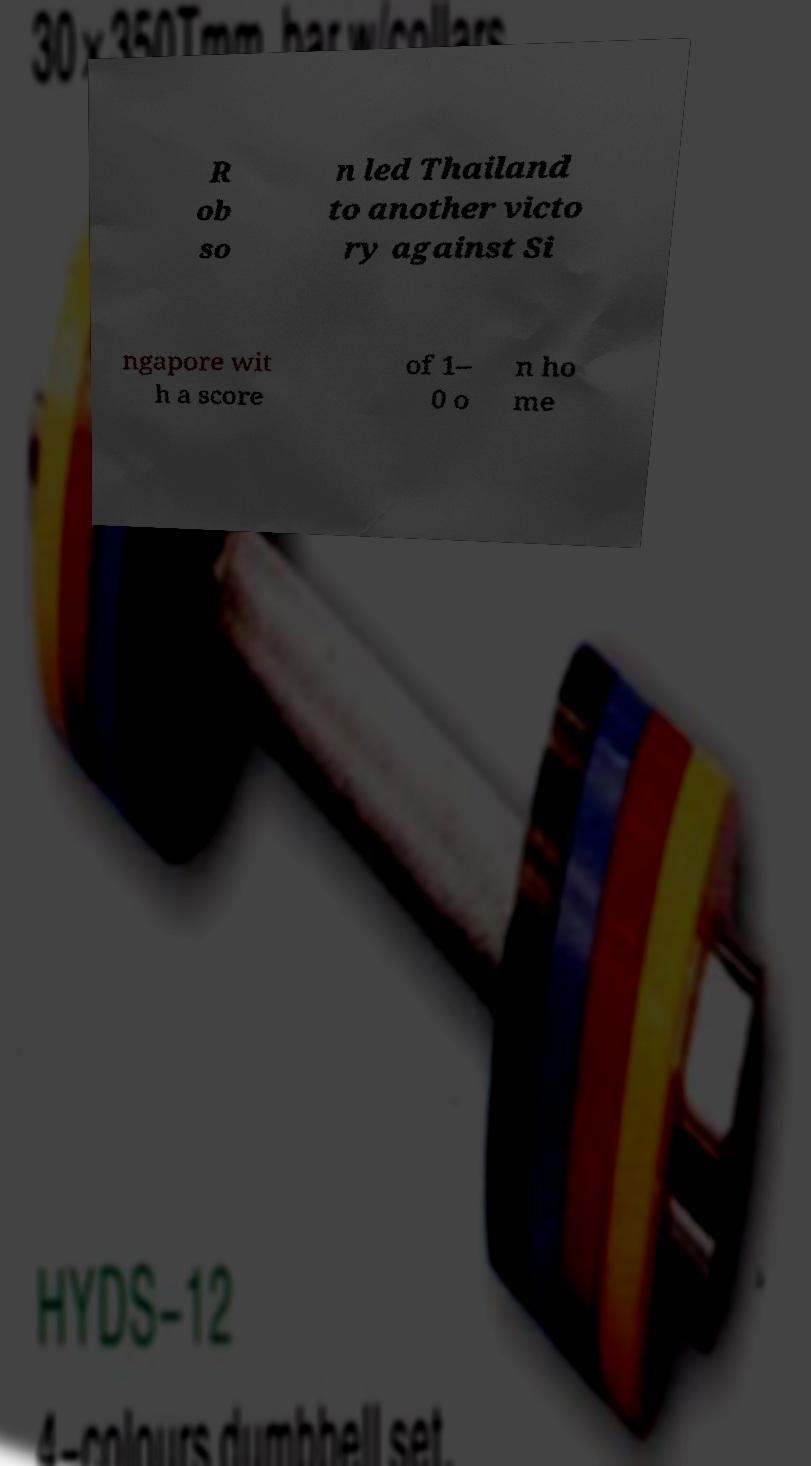What messages or text are displayed in this image? I need them in a readable, typed format. R ob so n led Thailand to another victo ry against Si ngapore wit h a score of 1– 0 o n ho me 